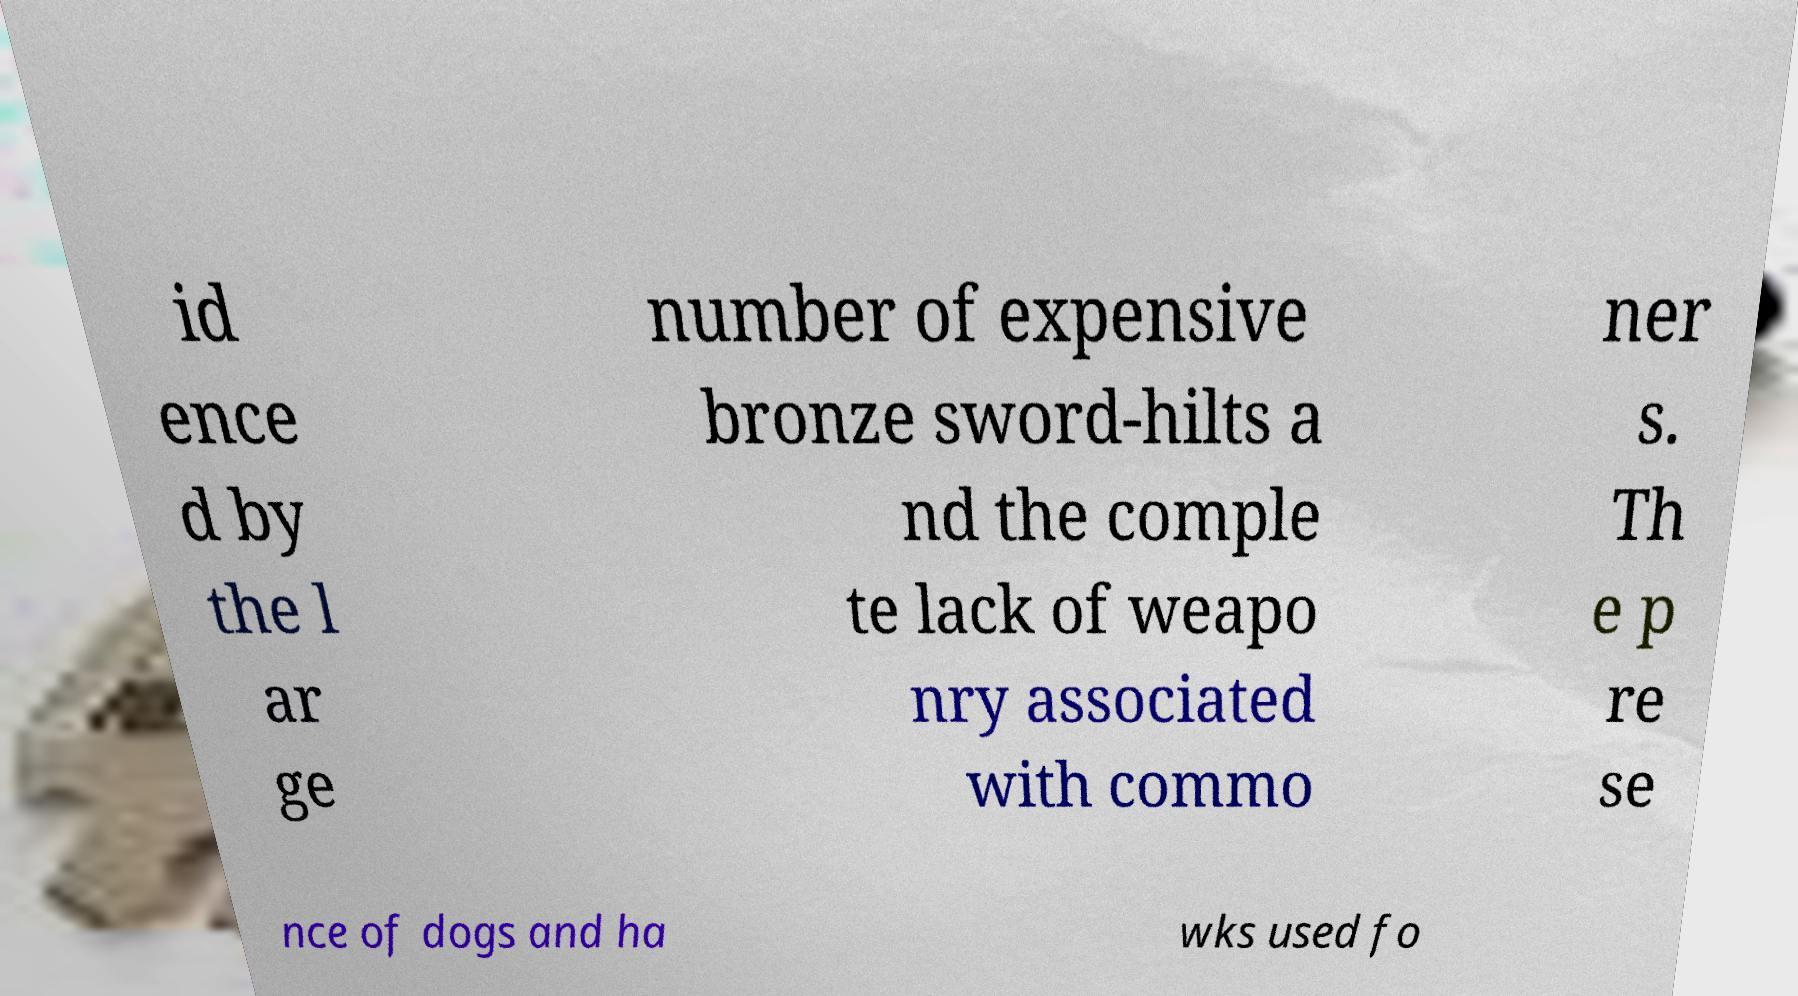There's text embedded in this image that I need extracted. Can you transcribe it verbatim? id ence d by the l ar ge number of expensive bronze sword-hilts a nd the comple te lack of weapo nry associated with commo ner s. Th e p re se nce of dogs and ha wks used fo 